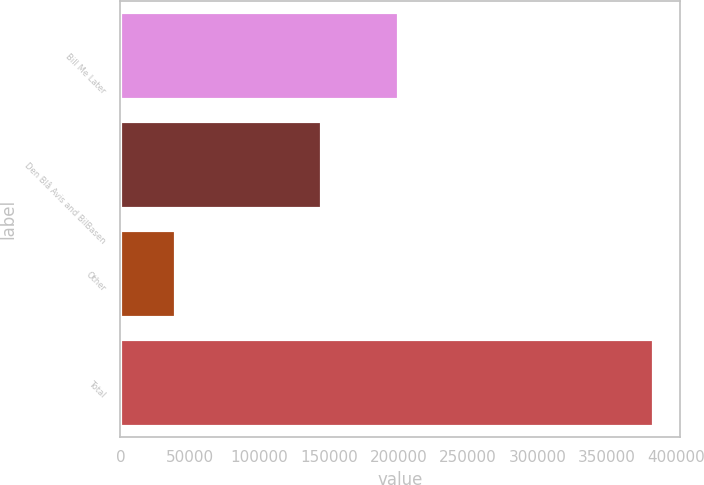Convert chart to OTSL. <chart><loc_0><loc_0><loc_500><loc_500><bar_chart><fcel>Bill Me Later<fcel>Den Blå Avis and BilBasen<fcel>Other<fcel>Total<nl><fcel>199600<fcel>144100<fcel>39417<fcel>383117<nl></chart> 